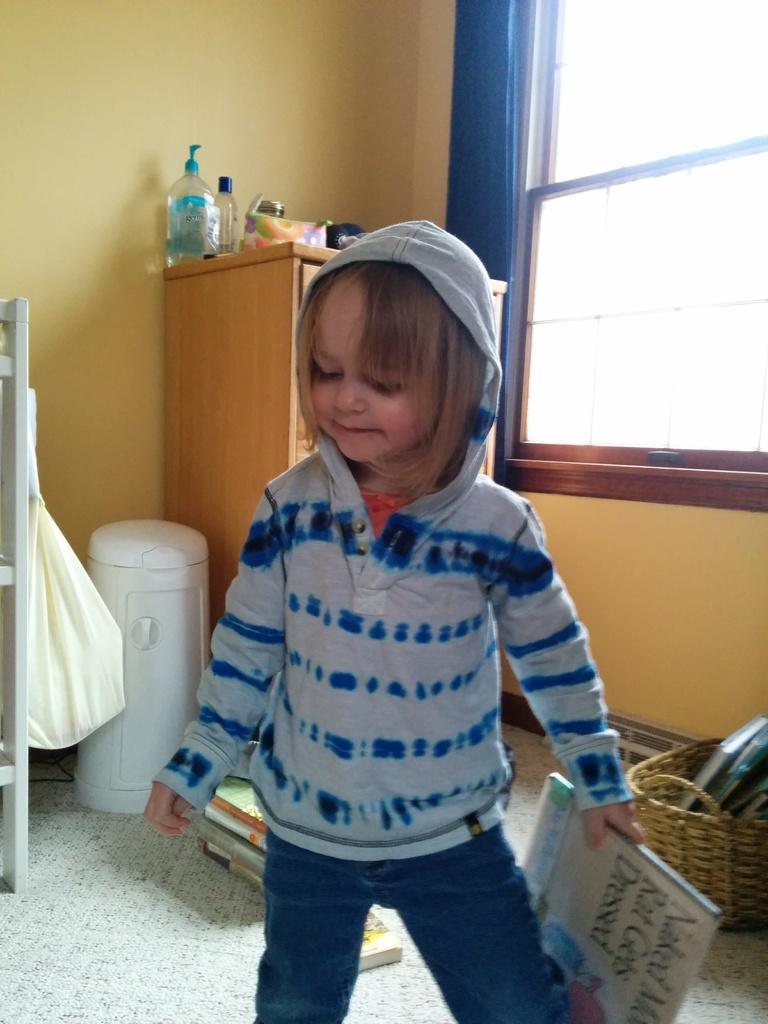How would you summarize this image in a sentence or two? In the center of the image we can see a kid standing on the floor and holding a book. In the background we can see basket, books, bottles, packet, cupboard, curtain and window. 